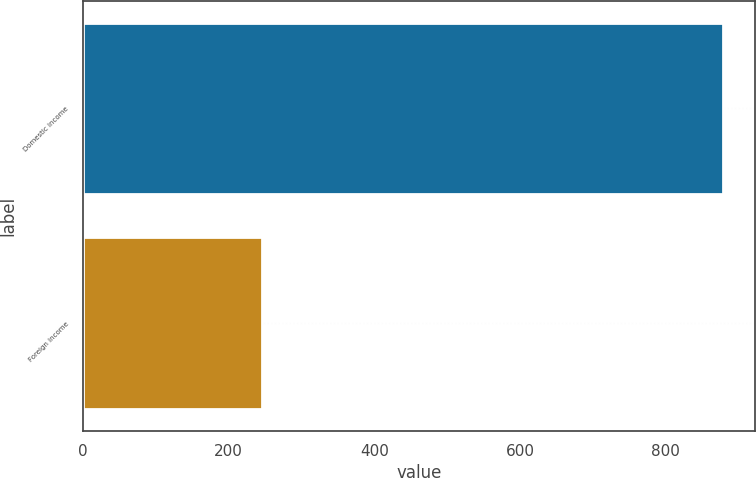Convert chart to OTSL. <chart><loc_0><loc_0><loc_500><loc_500><bar_chart><fcel>Domestic income<fcel>Foreign income<nl><fcel>879<fcel>245<nl></chart> 